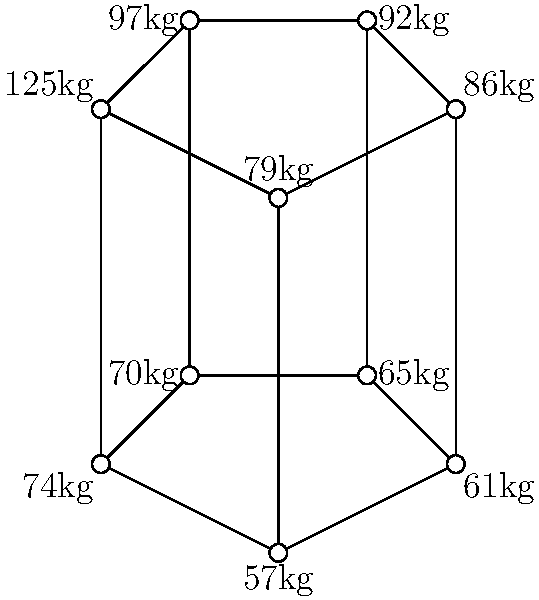In the given graph representation of wrestling weight classes, which weight class has the highest degree (most connections to other classes), and what strategic advantage might this offer for weight management? To solve this problem, we'll follow these steps:

1. Understand the graph representation:
   - Each node represents a weight class
   - Edges connect adjacent weight classes

2. Count the degree (number of connections) for each node:
   - 57kg: 3 connections
   - 61kg: 3 connections
   - 65kg: 3 connections
   - 70kg: 3 connections
   - 74kg: 3 connections
   - 79kg: 3 connections
   - 86kg: 3 connections
   - 92kg: 3 connections
   - 97kg: 3 connections
   - 125kg: 2 connections

3. Identify the weight class(es) with the highest degree:
   All weight classes except 125kg have 3 connections, which is the highest degree in this graph.

4. Analyze the strategic advantage:
   Weight classes with the highest degree (3 connections) offer more flexibility for weight management. A wrestler in these classes can:
   a) Move up one weight class
   b) Move down one weight class
   c) Stay in the current weight class

   This flexibility allows wrestlers to:
   - Adjust their weight based on competition strategy
   - Recover more easily from minor weight fluctuations
   - Have more options for entering tournaments at different weight classes

The 125kg class, with only 2 connections, has less flexibility as wrestlers can only move down or stay in the same class.
Answer: All classes except 125kg; more weight management options. 